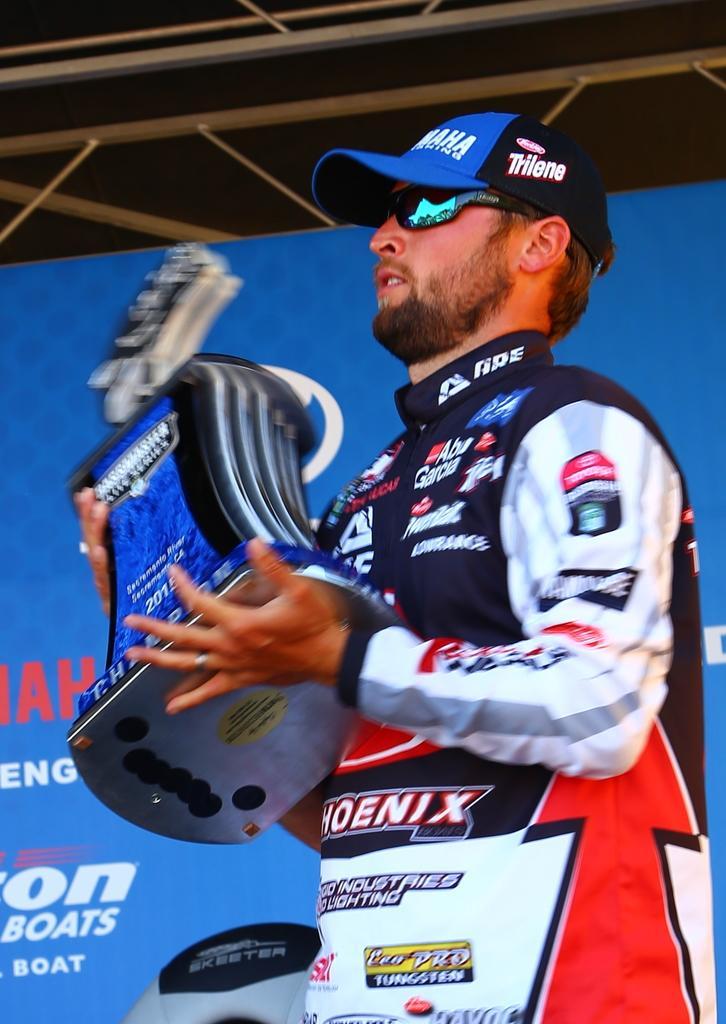Can you describe this image briefly? In this picture there is a man standing and holding the object. At the back there is a hoarding and there is text on the hoarding. At the top there are rods. 